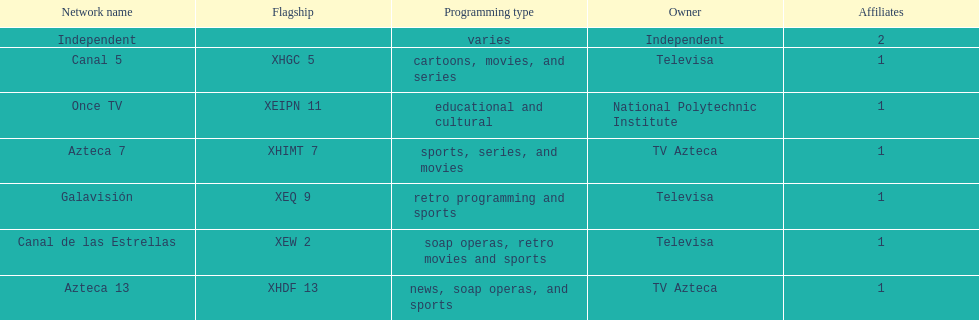Would you be able to parse every entry in this table? {'header': ['Network name', 'Flagship', 'Programming type', 'Owner', 'Affiliates'], 'rows': [['Independent', '', 'varies', 'Independent', '2'], ['Canal 5', 'XHGC 5', 'cartoons, movies, and series', 'Televisa', '1'], ['Once TV', 'XEIPN 11', 'educational and cultural', 'National Polytechnic Institute', '1'], ['Azteca 7', 'XHIMT 7', 'sports, series, and movies', 'TV Azteca', '1'], ['Galavisión', 'XEQ 9', 'retro programming and sports', 'Televisa', '1'], ['Canal de las Estrellas', 'XEW 2', 'soap operas, retro movies and sports', 'Televisa', '1'], ['Azteca 13', 'XHDF 13', 'news, soap operas, and sports', 'TV Azteca', '1']]} How many networks does tv azteca own? 2. 